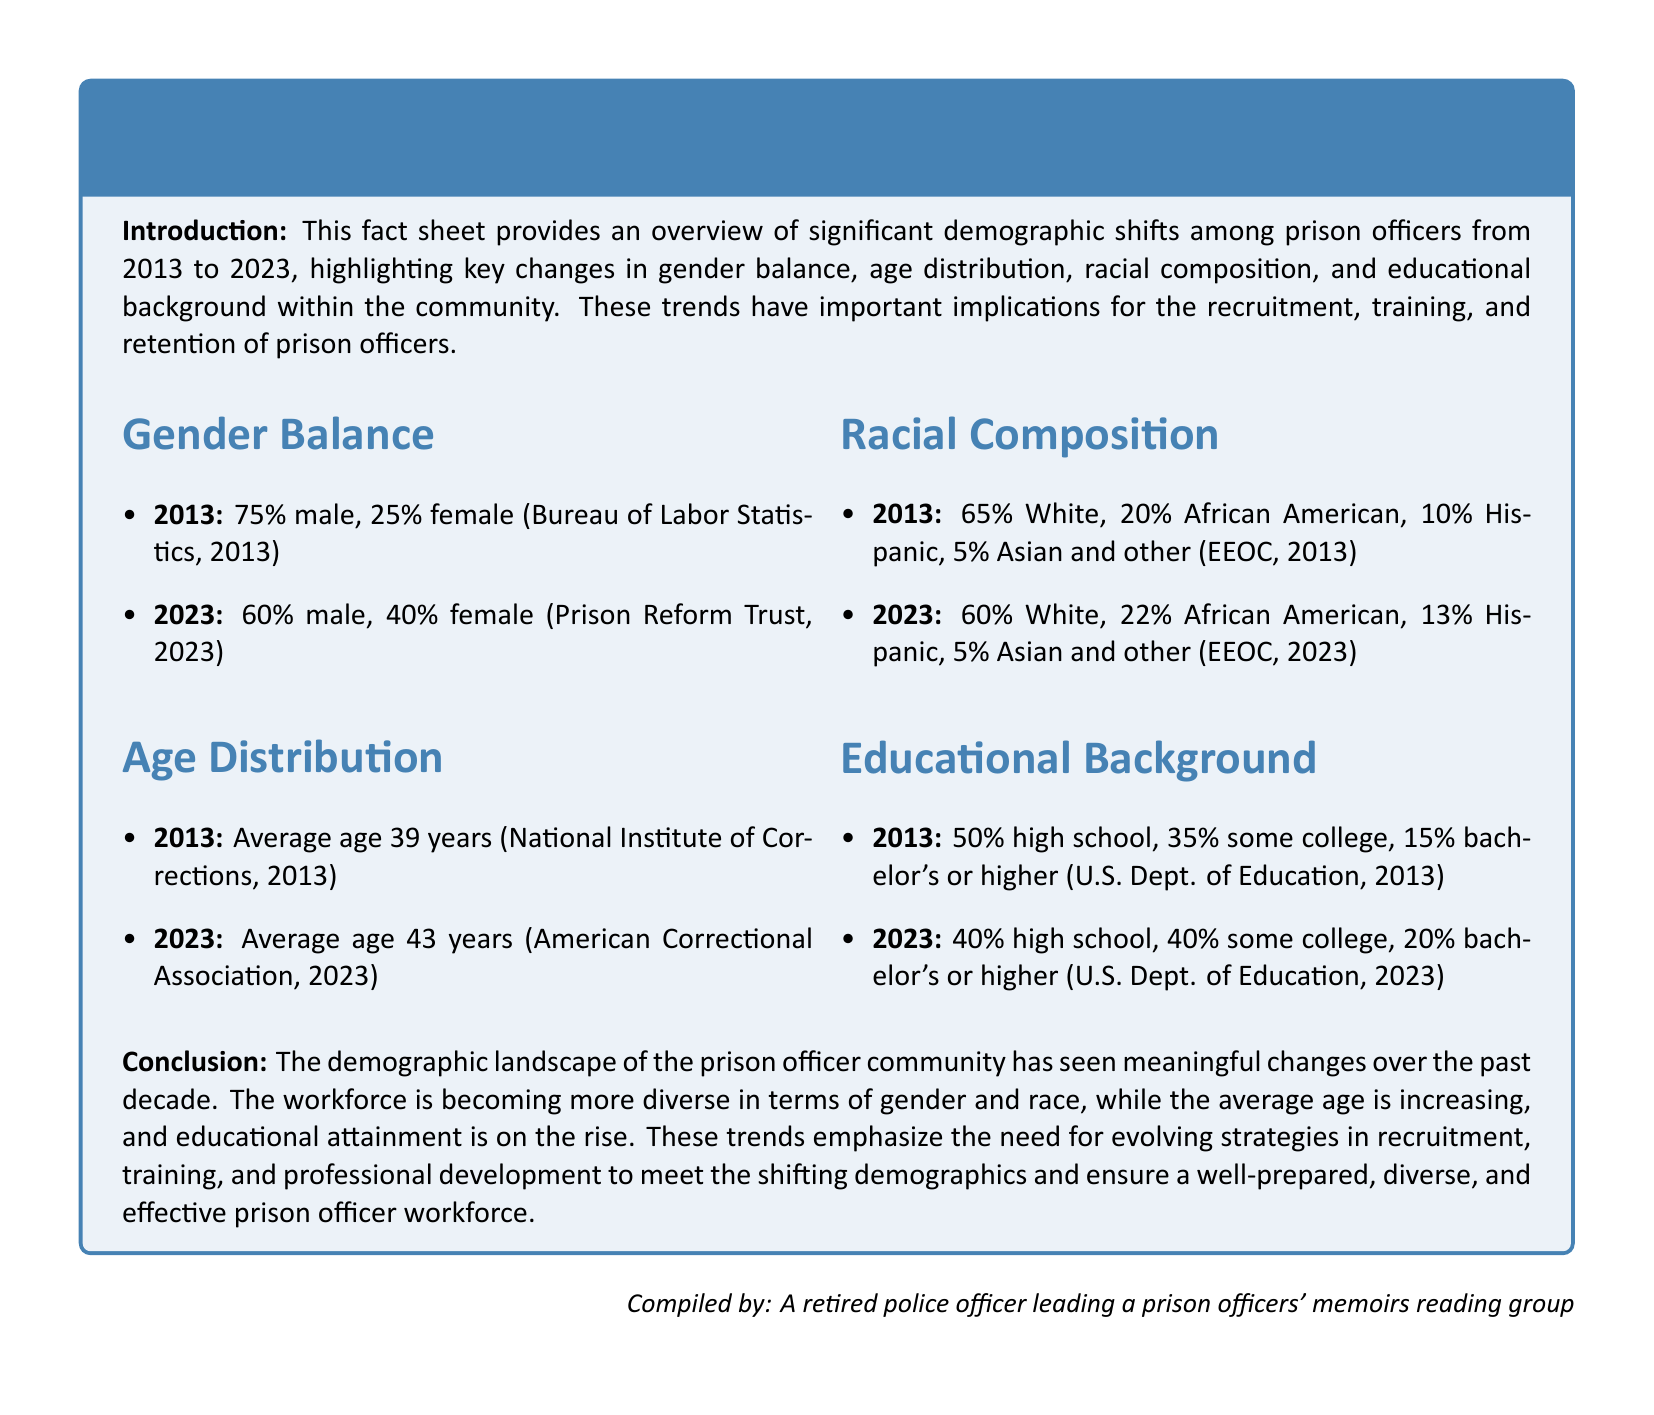What was the percentage of male prison officers in 2013? The document states that 75% of prison officers were male in 2013.
Answer: 75% What is the average age of prison officers in 2023? According to the document, the average age of prison officers in 2023 is 43 years.
Answer: 43 years What percentage of prison officers identified as Hispanic in 2013? The document indicates that 10% of prison officers identified as Hispanic in 2013.
Answer: 10% What is the percentage of prison officers with a bachelor's degree or higher in 2023? The document mentions that 20% of prison officers had a bachelor's degree or higher in 2023.
Answer: 20% What does the increasing average age of prison officers imply about recruitment strategies? The document implies that evolving strategies will be necessary to accommodate an aging workforce.
Answer: Evolving strategies What was the racial composition of prison officers in 2023 for African American? The document states that 22% of prison officers identified as African American in 2023.
Answer: 22% How has the gender balance among prison officers changed from 2013 to 2023? The document shows that the percentage of male officers decreased from 75% in 2013 to 60% in 2023.
Answer: Decreased from 75% to 60% What was the percentage of prison officers with high school education in 2013? The document indicates that 50% of prison officers had a high school education in 2013.
Answer: 50% What are the implications of the demographic trends highlighted in the document? The document emphasizes the need for strategies in recruitment, training, and retention due to changing demographics.
Answer: Strategies in recruitment, training, and retention 